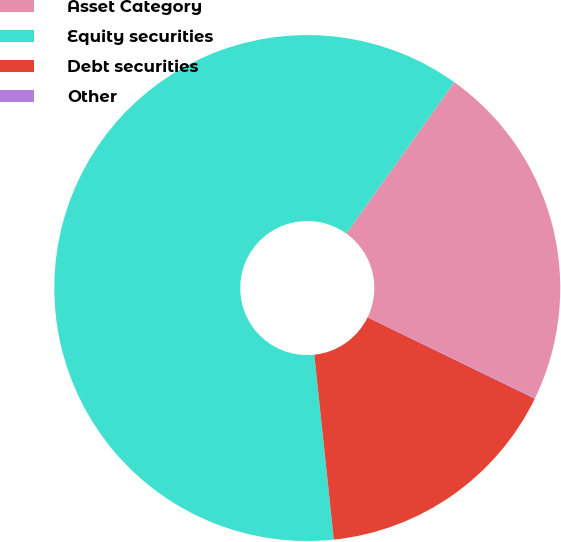<chart> <loc_0><loc_0><loc_500><loc_500><pie_chart><fcel>Asset Category<fcel>Equity securities<fcel>Debt securities<fcel>Other<nl><fcel>22.28%<fcel>61.55%<fcel>16.13%<fcel>0.05%<nl></chart> 